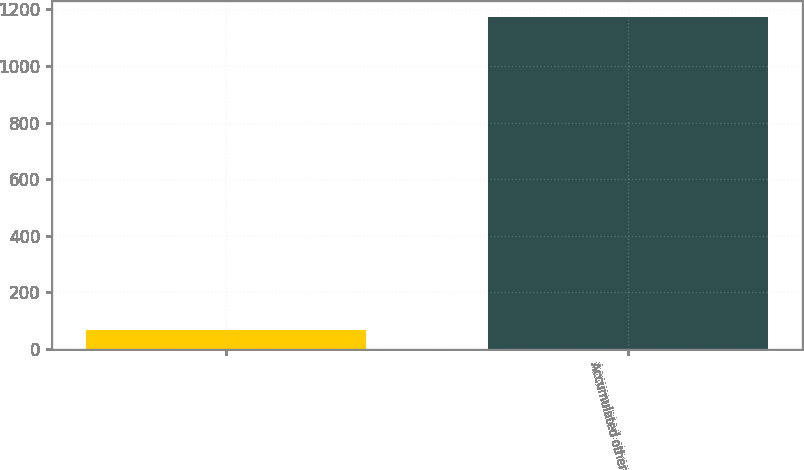Convert chart to OTSL. <chart><loc_0><loc_0><loc_500><loc_500><bar_chart><ecel><fcel>Accumulated other<nl><fcel>66<fcel>1171<nl></chart> 